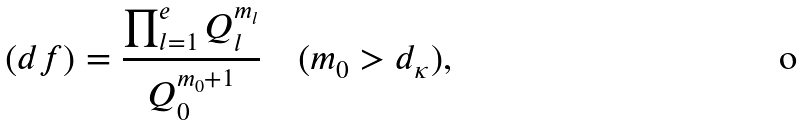<formula> <loc_0><loc_0><loc_500><loc_500>( d f ) = \frac { \prod _ { l = 1 } ^ { e } Q _ { l } ^ { m _ { l } } } { Q _ { 0 } ^ { m _ { 0 } + 1 } } \quad ( m _ { 0 } > d _ { \kappa } ) ,</formula> 